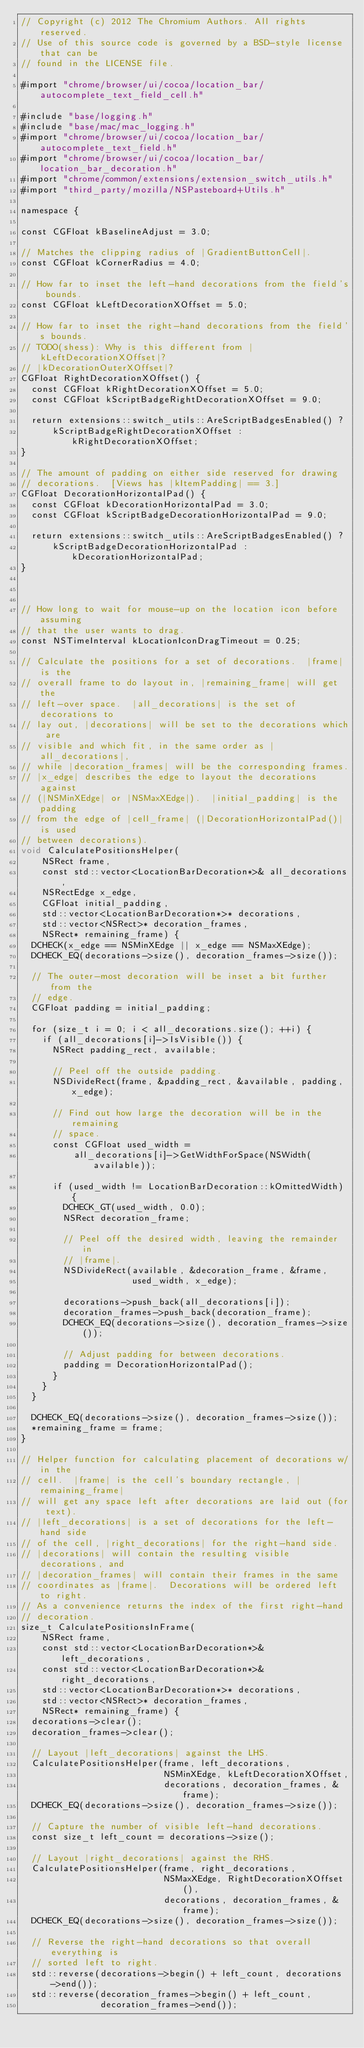Convert code to text. <code><loc_0><loc_0><loc_500><loc_500><_ObjectiveC_>// Copyright (c) 2012 The Chromium Authors. All rights reserved.
// Use of this source code is governed by a BSD-style license that can be
// found in the LICENSE file.

#import "chrome/browser/ui/cocoa/location_bar/autocomplete_text_field_cell.h"

#include "base/logging.h"
#include "base/mac/mac_logging.h"
#import "chrome/browser/ui/cocoa/location_bar/autocomplete_text_field.h"
#import "chrome/browser/ui/cocoa/location_bar/location_bar_decoration.h"
#import "chrome/common/extensions/extension_switch_utils.h"
#import "third_party/mozilla/NSPasteboard+Utils.h"

namespace {

const CGFloat kBaselineAdjust = 3.0;

// Matches the clipping radius of |GradientButtonCell|.
const CGFloat kCornerRadius = 4.0;

// How far to inset the left-hand decorations from the field's bounds.
const CGFloat kLeftDecorationXOffset = 5.0;

// How far to inset the right-hand decorations from the field's bounds.
// TODO(shess): Why is this different from |kLeftDecorationXOffset|?
// |kDecorationOuterXOffset|?
CGFloat RightDecorationXOffset() {
  const CGFloat kRightDecorationXOffset = 5.0;
  const CGFloat kScriptBadgeRightDecorationXOffset = 9.0;

  return extensions::switch_utils::AreScriptBadgesEnabled() ?
      kScriptBadgeRightDecorationXOffset : kRightDecorationXOffset;
}

// The amount of padding on either side reserved for drawing
// decorations.  [Views has |kItemPadding| == 3.]
CGFloat DecorationHorizontalPad() {
  const CGFloat kDecorationHorizontalPad = 3.0;
  const CGFloat kScriptBadgeDecorationHorizontalPad = 9.0;

  return extensions::switch_utils::AreScriptBadgesEnabled() ?
      kScriptBadgeDecorationHorizontalPad : kDecorationHorizontalPad;
}



// How long to wait for mouse-up on the location icon before assuming
// that the user wants to drag.
const NSTimeInterval kLocationIconDragTimeout = 0.25;

// Calculate the positions for a set of decorations.  |frame| is the
// overall frame to do layout in, |remaining_frame| will get the
// left-over space.  |all_decorations| is the set of decorations to
// lay out, |decorations| will be set to the decorations which are
// visible and which fit, in the same order as |all_decorations|,
// while |decoration_frames| will be the corresponding frames.
// |x_edge| describes the edge to layout the decorations against
// (|NSMinXEdge| or |NSMaxXEdge|).  |initial_padding| is the padding
// from the edge of |cell_frame| (|DecorationHorizontalPad()| is used
// between decorations).
void CalculatePositionsHelper(
    NSRect frame,
    const std::vector<LocationBarDecoration*>& all_decorations,
    NSRectEdge x_edge,
    CGFloat initial_padding,
    std::vector<LocationBarDecoration*>* decorations,
    std::vector<NSRect>* decoration_frames,
    NSRect* remaining_frame) {
  DCHECK(x_edge == NSMinXEdge || x_edge == NSMaxXEdge);
  DCHECK_EQ(decorations->size(), decoration_frames->size());

  // The outer-most decoration will be inset a bit further from the
  // edge.
  CGFloat padding = initial_padding;

  for (size_t i = 0; i < all_decorations.size(); ++i) {
    if (all_decorations[i]->IsVisible()) {
      NSRect padding_rect, available;

      // Peel off the outside padding.
      NSDivideRect(frame, &padding_rect, &available, padding, x_edge);

      // Find out how large the decoration will be in the remaining
      // space.
      const CGFloat used_width =
          all_decorations[i]->GetWidthForSpace(NSWidth(available));

      if (used_width != LocationBarDecoration::kOmittedWidth) {
        DCHECK_GT(used_width, 0.0);
        NSRect decoration_frame;

        // Peel off the desired width, leaving the remainder in
        // |frame|.
        NSDivideRect(available, &decoration_frame, &frame,
                     used_width, x_edge);

        decorations->push_back(all_decorations[i]);
        decoration_frames->push_back(decoration_frame);
        DCHECK_EQ(decorations->size(), decoration_frames->size());

        // Adjust padding for between decorations.
        padding = DecorationHorizontalPad();
      }
    }
  }

  DCHECK_EQ(decorations->size(), decoration_frames->size());
  *remaining_frame = frame;
}

// Helper function for calculating placement of decorations w/in the
// cell.  |frame| is the cell's boundary rectangle, |remaining_frame|
// will get any space left after decorations are laid out (for text).
// |left_decorations| is a set of decorations for the left-hand side
// of the cell, |right_decorations| for the right-hand side.
// |decorations| will contain the resulting visible decorations, and
// |decoration_frames| will contain their frames in the same
// coordinates as |frame|.  Decorations will be ordered left to right.
// As a convenience returns the index of the first right-hand
// decoration.
size_t CalculatePositionsInFrame(
    NSRect frame,
    const std::vector<LocationBarDecoration*>& left_decorations,
    const std::vector<LocationBarDecoration*>& right_decorations,
    std::vector<LocationBarDecoration*>* decorations,
    std::vector<NSRect>* decoration_frames,
    NSRect* remaining_frame) {
  decorations->clear();
  decoration_frames->clear();

  // Layout |left_decorations| against the LHS.
  CalculatePositionsHelper(frame, left_decorations,
                           NSMinXEdge, kLeftDecorationXOffset,
                           decorations, decoration_frames, &frame);
  DCHECK_EQ(decorations->size(), decoration_frames->size());

  // Capture the number of visible left-hand decorations.
  const size_t left_count = decorations->size();

  // Layout |right_decorations| against the RHS.
  CalculatePositionsHelper(frame, right_decorations,
                           NSMaxXEdge, RightDecorationXOffset(),
                           decorations, decoration_frames, &frame);
  DCHECK_EQ(decorations->size(), decoration_frames->size());

  // Reverse the right-hand decorations so that overall everything is
  // sorted left to right.
  std::reverse(decorations->begin() + left_count, decorations->end());
  std::reverse(decoration_frames->begin() + left_count,
               decoration_frames->end());
</code> 